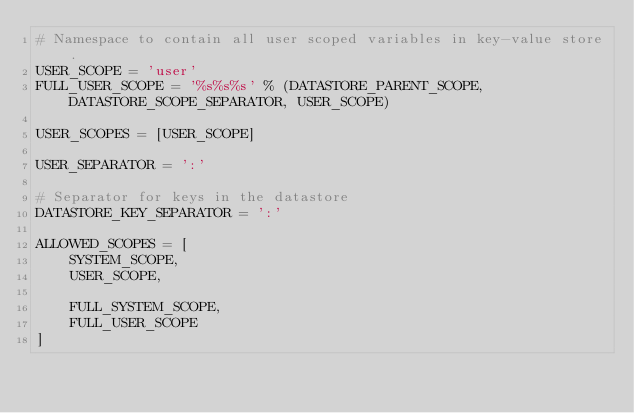<code> <loc_0><loc_0><loc_500><loc_500><_Python_># Namespace to contain all user scoped variables in key-value store.
USER_SCOPE = 'user'
FULL_USER_SCOPE = '%s%s%s' % (DATASTORE_PARENT_SCOPE, DATASTORE_SCOPE_SEPARATOR, USER_SCOPE)

USER_SCOPES = [USER_SCOPE]

USER_SEPARATOR = ':'

# Separator for keys in the datastore
DATASTORE_KEY_SEPARATOR = ':'

ALLOWED_SCOPES = [
    SYSTEM_SCOPE,
    USER_SCOPE,

    FULL_SYSTEM_SCOPE,
    FULL_USER_SCOPE
]
</code> 